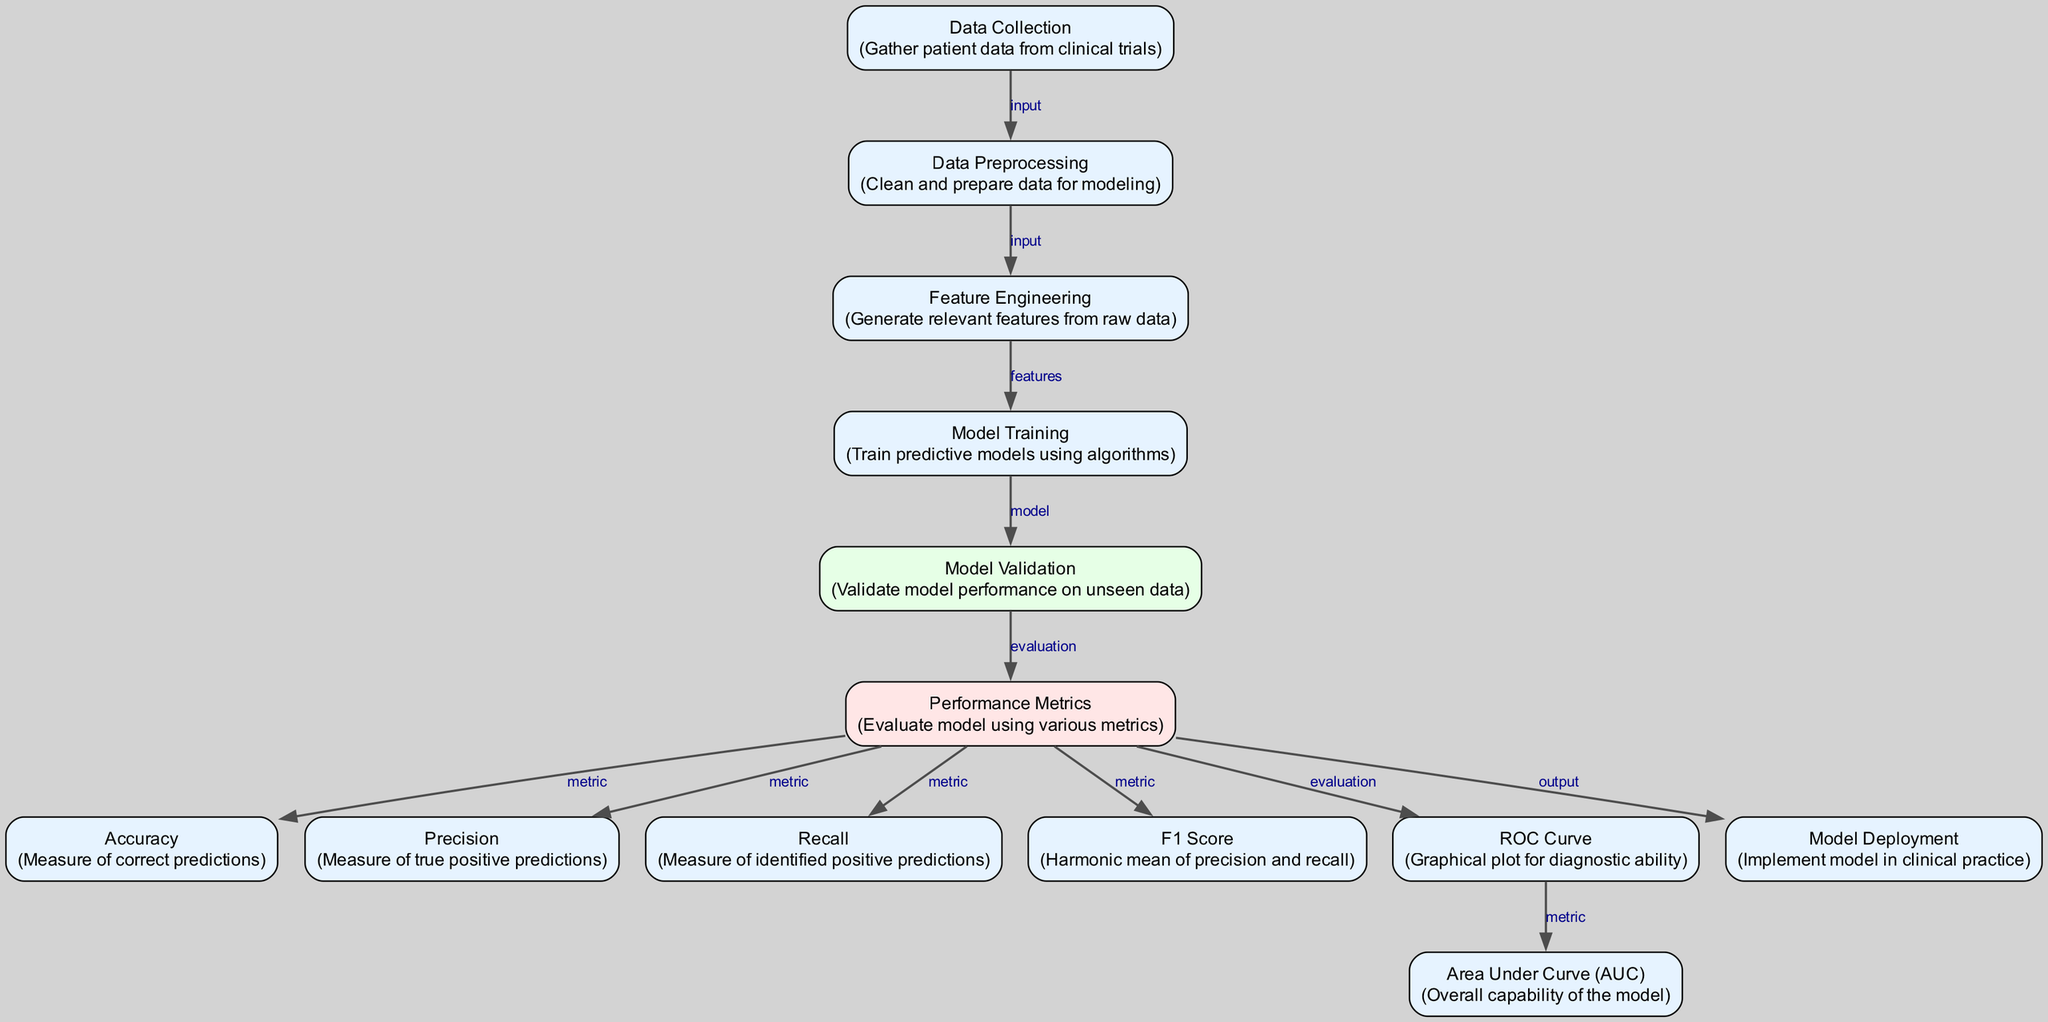What is the first step in the diagram? The first step, according to the diagram, is "Data Collection," which indicates the process of gathering patient data from clinical trials. This is the initial action taken in the workflow.
Answer: Data Collection How many performance metrics are listed in the diagram? The diagram lists five performance metrics: Accuracy, Precision, Recall, F1 Score, and Area Under Curve (AUC). Each of these metrics is clearly labeled within the Performance Metrics node.
Answer: Five Which process directly follows "Model Validation"? The process that follows "Model Validation" is "Performance Metrics." This connection signifies that after validating a model, the next step is to evaluate its performance using various metrics.
Answer: Performance Metrics Which metric represents the overall capability of the model? The metric that represents the overall capability of the model is "Area Under Curve (AUC)." This term specifically refers to the ability of a model to distinguish between different outcomes, summarized in this single metric.
Answer: Area Under Curve (AUC) What type of edge connects "Model Validation" and "Performance Metrics"? The type of edge connecting "Model Validation" and "Performance Metrics" is labeled "evaluation." This indicates that the performance metrics are an evaluative step following model validation, showing how the model's performance is measured.
Answer: Evaluation What happens to the model after Performance Metrics are calculated? After Performance Metrics are calculated, the next step is "Model Deployment," which indicates the implementation of the trained model into clinical practice for real-world application.
Answer: Model Deployment Which metric is the harmonic mean of precision and recall? The metric that is the harmonic mean of precision and recall is the "F1 Score." This statistic combines both precision and recall into a single score to balance the two measurements.
Answer: F1 Score Between which two nodes is "Feature Engineering" positioned? "Feature Engineering" is positioned between "Data Preprocessing" and "Model Training," indicating that it occurs after data has been cleaned and prepared, and before the models are trained.
Answer: Data Preprocessing and Model Training 